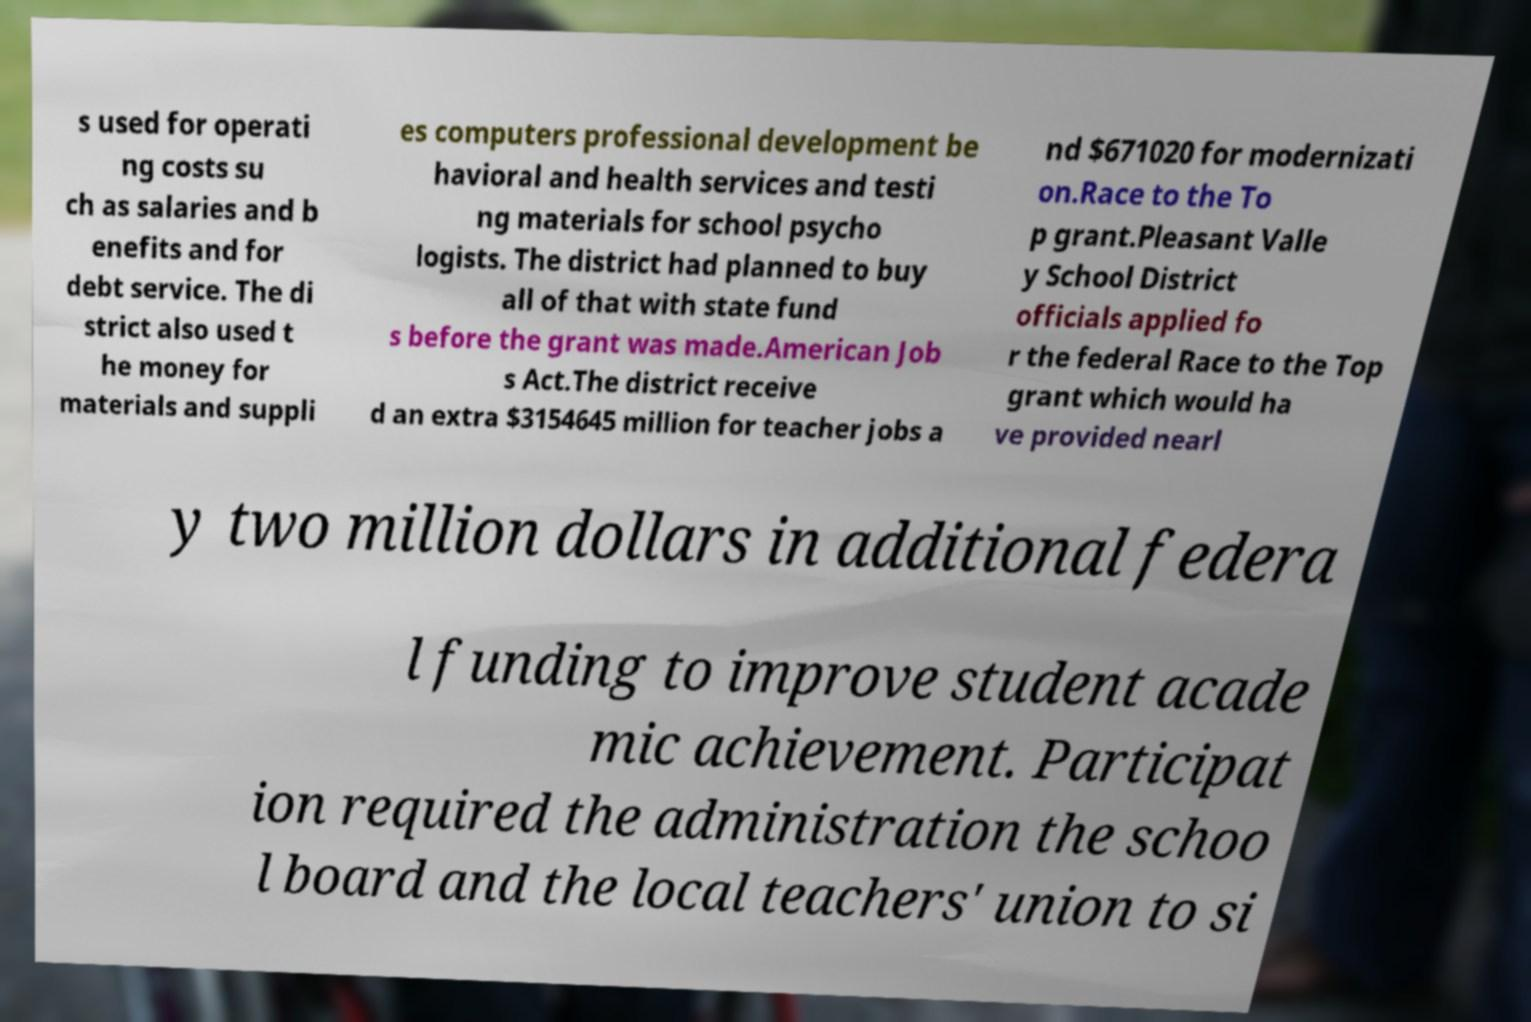There's text embedded in this image that I need extracted. Can you transcribe it verbatim? s used for operati ng costs su ch as salaries and b enefits and for debt service. The di strict also used t he money for materials and suppli es computers professional development be havioral and health services and testi ng materials for school psycho logists. The district had planned to buy all of that with state fund s before the grant was made.American Job s Act.The district receive d an extra $3154645 million for teacher jobs a nd $671020 for modernizati on.Race to the To p grant.Pleasant Valle y School District officials applied fo r the federal Race to the Top grant which would ha ve provided nearl y two million dollars in additional federa l funding to improve student acade mic achievement. Participat ion required the administration the schoo l board and the local teachers' union to si 